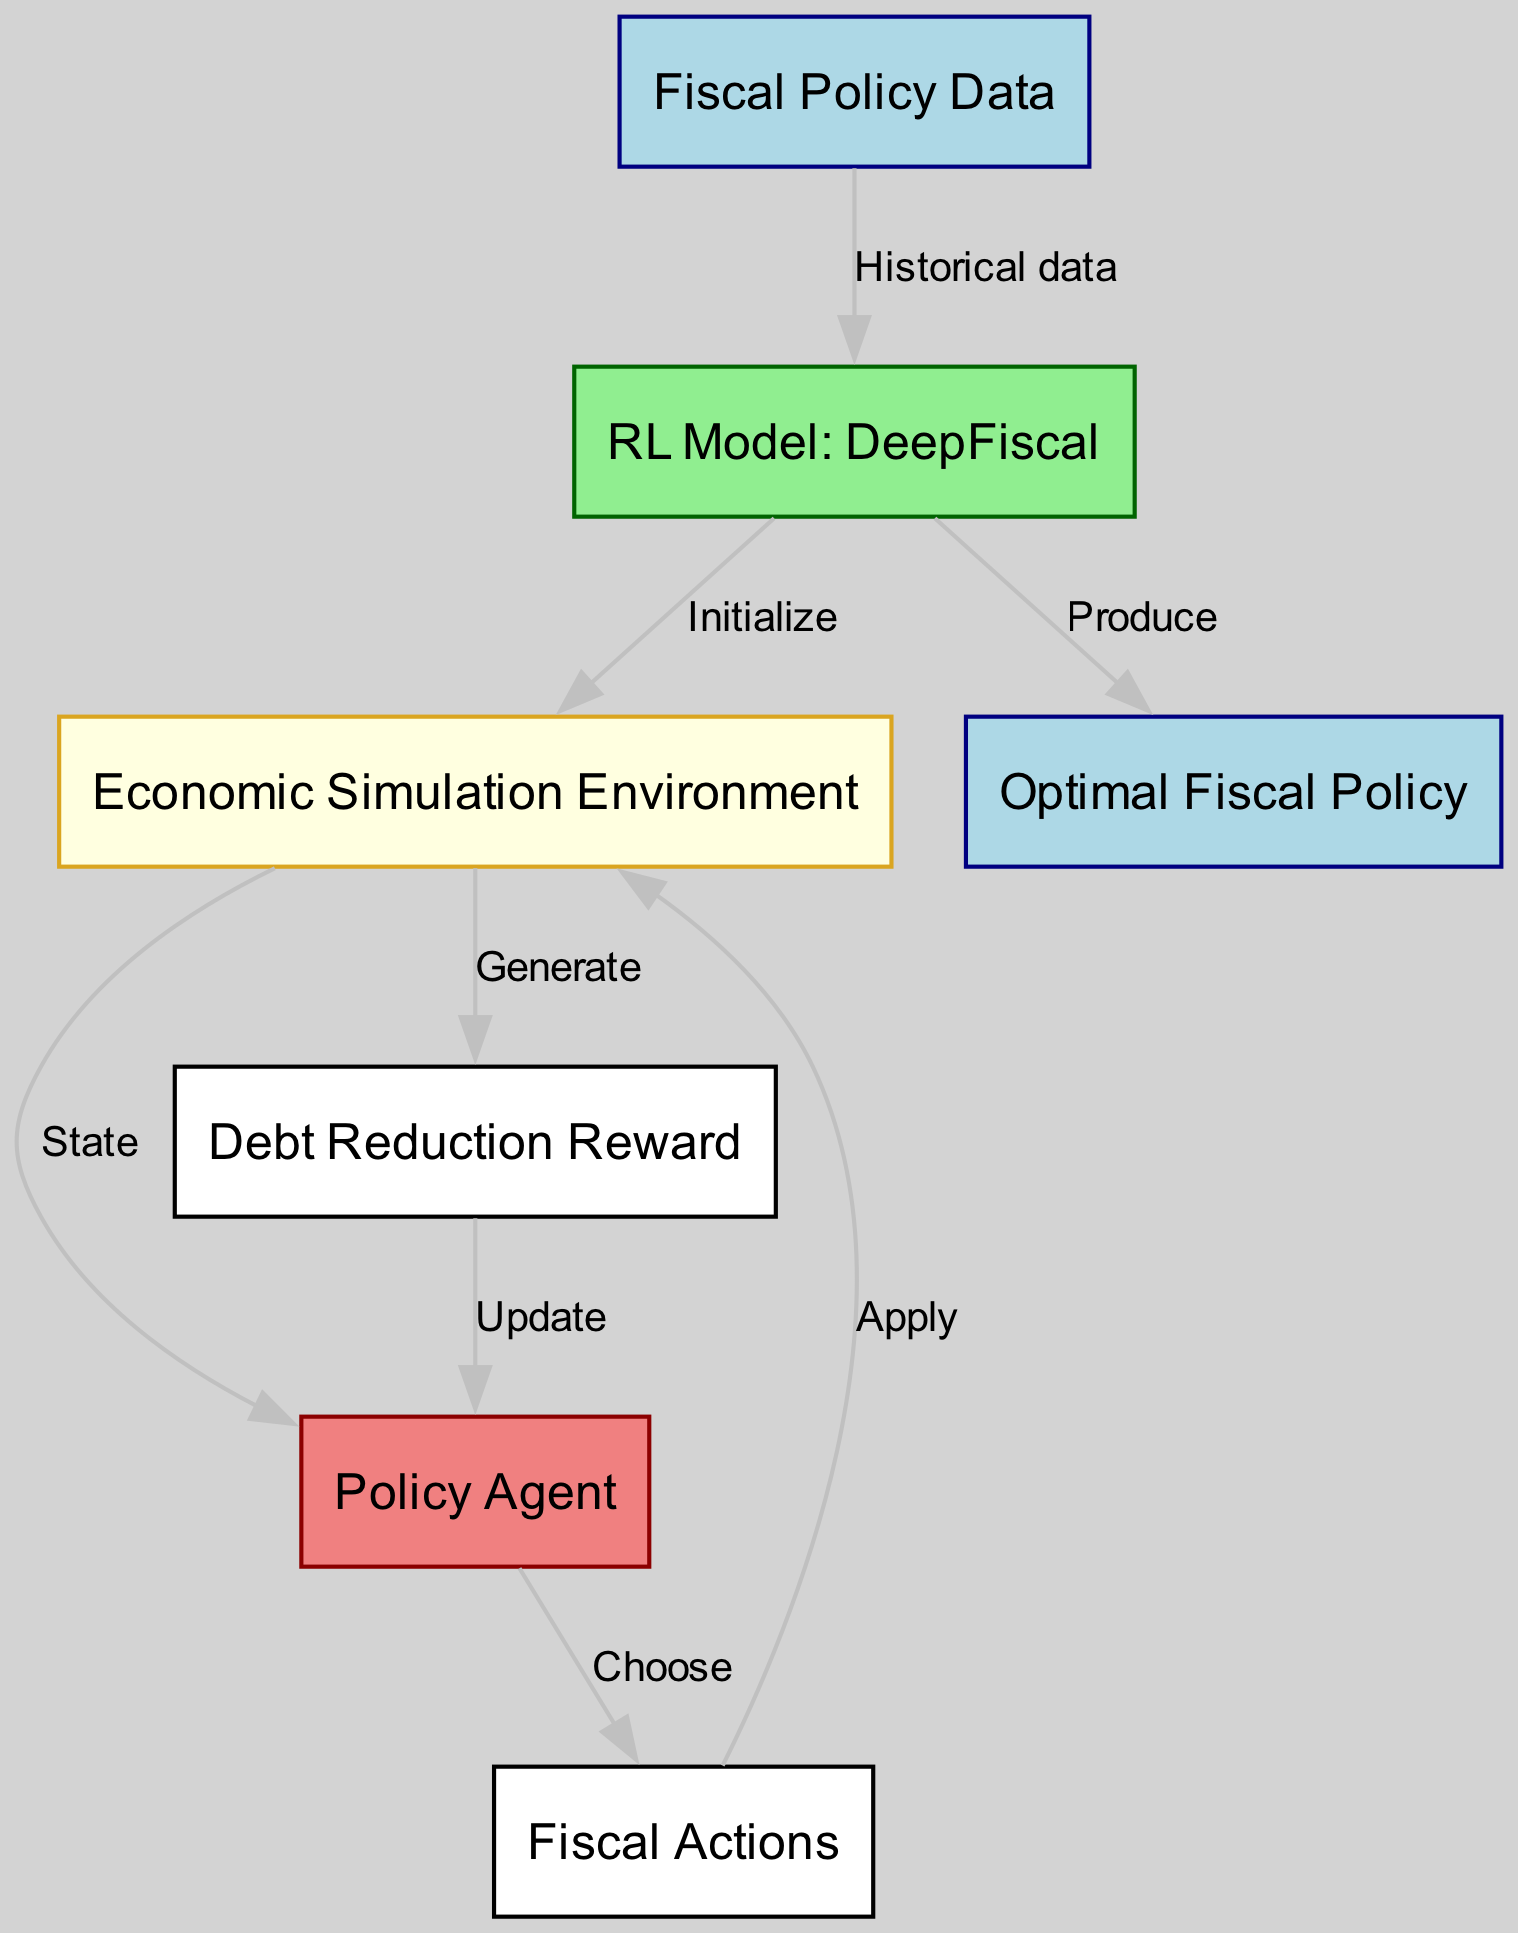What is the total number of nodes in the diagram? By counting the nodes listed in the diagram data, there are seven nodes: Fiscal Policy Data, RL Model: DeepFiscal, Economic Simulation Environment, Policy Agent, Fiscal Actions, Debt Reduction Reward, and Optimal Fiscal Policy.
Answer: 7 What type of model is represented in the diagram? The diagram identifies a specific model indicated by the label "RL Model: DeepFiscal." This refers to a reinforcement learning model focused on fiscal policy.
Answer: RL Model: DeepFiscal Which node generates the Debt Reduction Reward? The "Economic Simulation Environment" node is connected to the "Debt Reduction Reward" node through the "Generate" edge. It indicates that the reward is generated based on the economic simulation results.
Answer: Economic Simulation Environment What action does the Policy Agent choose in the diagram? The "Policy Agent" node is linked to the "Fiscal Actions" node with the label "Choose," indicating that the Policy Agent selects specific fiscal actions based on the current state.
Answer: Fiscal Actions What is the final output of the reinforcement learning model? The "Optimal Fiscal Policy" node is the endpoint of the diagram, connected to the "RL Model: DeepFiscal" by the "Produce" edge, signifying that the model's outcome is the optimal fiscal policy.
Answer: Optimal Fiscal Policy How many edges are there in the diagram? The total number of edges can be counted based on the connections provided in the data. There are eight edges connecting the various nodes in the diagram.
Answer: 8 After applying fiscal actions, what does the environment output? The "Economic Simulation Environment" node is connected to the "Debt Reduction Reward" node with the edge labeled "Generate," indicating that the environment produces the debt reduction reward based on the applied actions.
Answer: Debt Reduction Reward Which node receives updates from the Debt Reduction Reward? The "Policy Agent" node receives updates from the "Debt Reduction Reward" node via the "Update" edge, indicating that it uses the reward information to adjust its future actions.
Answer: Policy Agent How does the model utilize historical data? The "Fiscal Policy Data" node sends historical data to the "RL Model: DeepFiscal" through the "Historical data" edge, which the model uses to initialize and train its simulations.
Answer: RL Model: DeepFiscal 